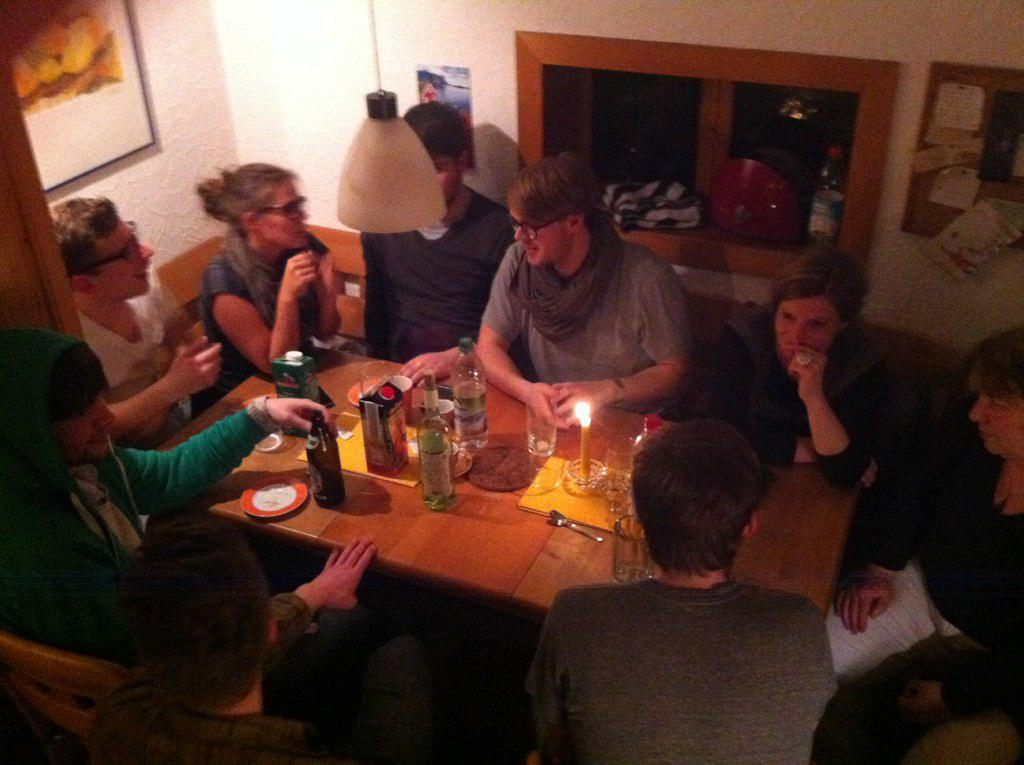What are the people in the image doing? People are sitting on chairs near a table in the image. What objects can be seen on the table? There is a bottle, a glass, a candle, and a saucer on the table. What is hanging on the wall? There is a light fixture and a photo frame on the wall. How many eggs are visible in the image? There are no eggs present in the image. What is the profit margin of the business depicted in the image? There is no indication of a business or profit margin in the image. 